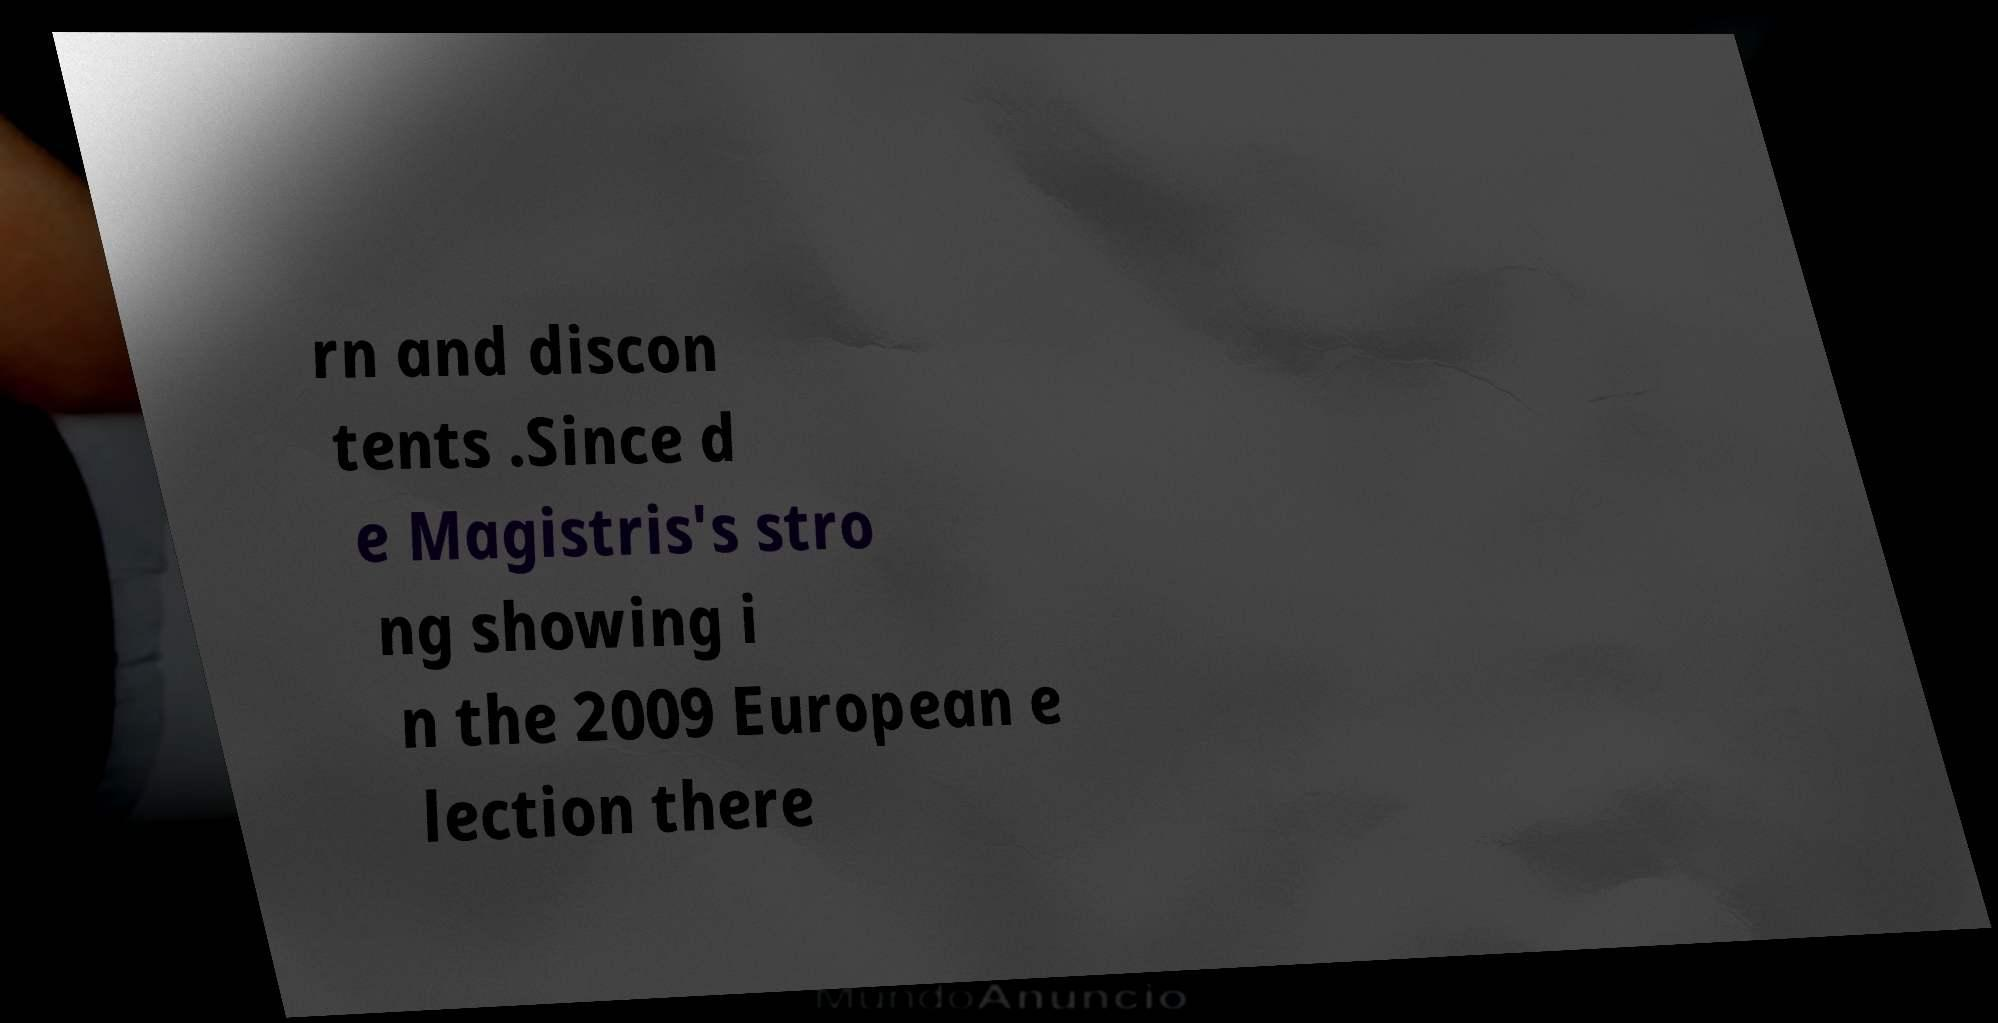I need the written content from this picture converted into text. Can you do that? rn and discon tents .Since d e Magistris's stro ng showing i n the 2009 European e lection there 